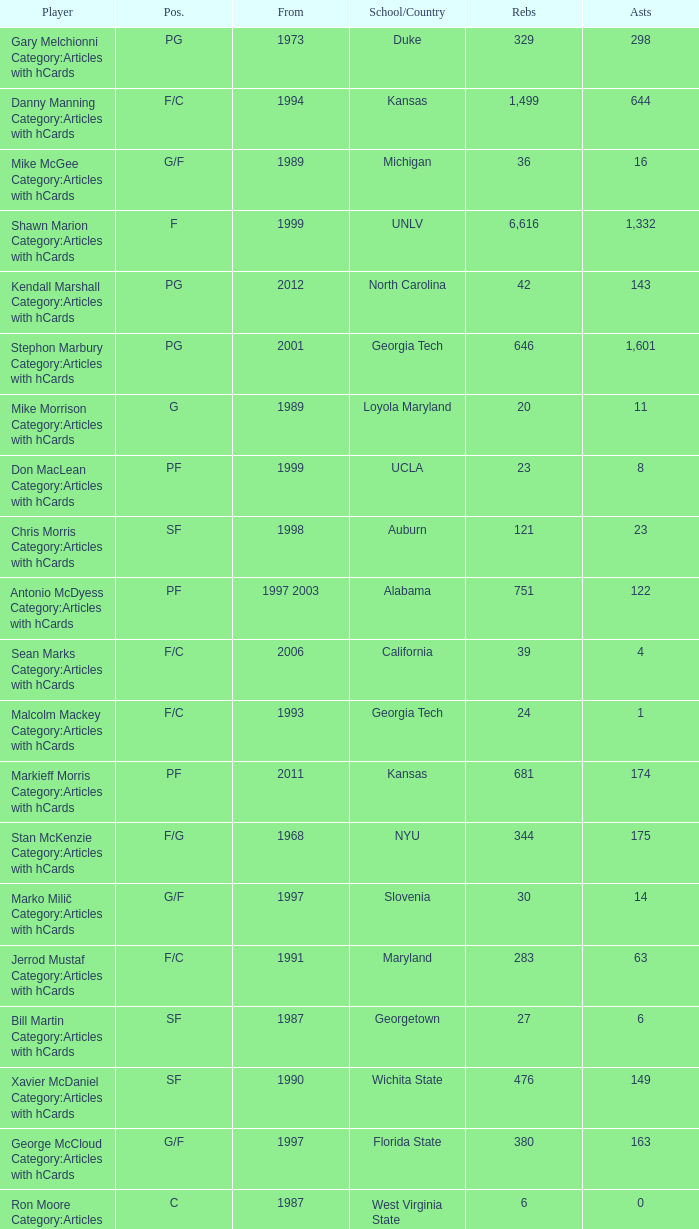Who has the high assists in 2000? 16.0. 